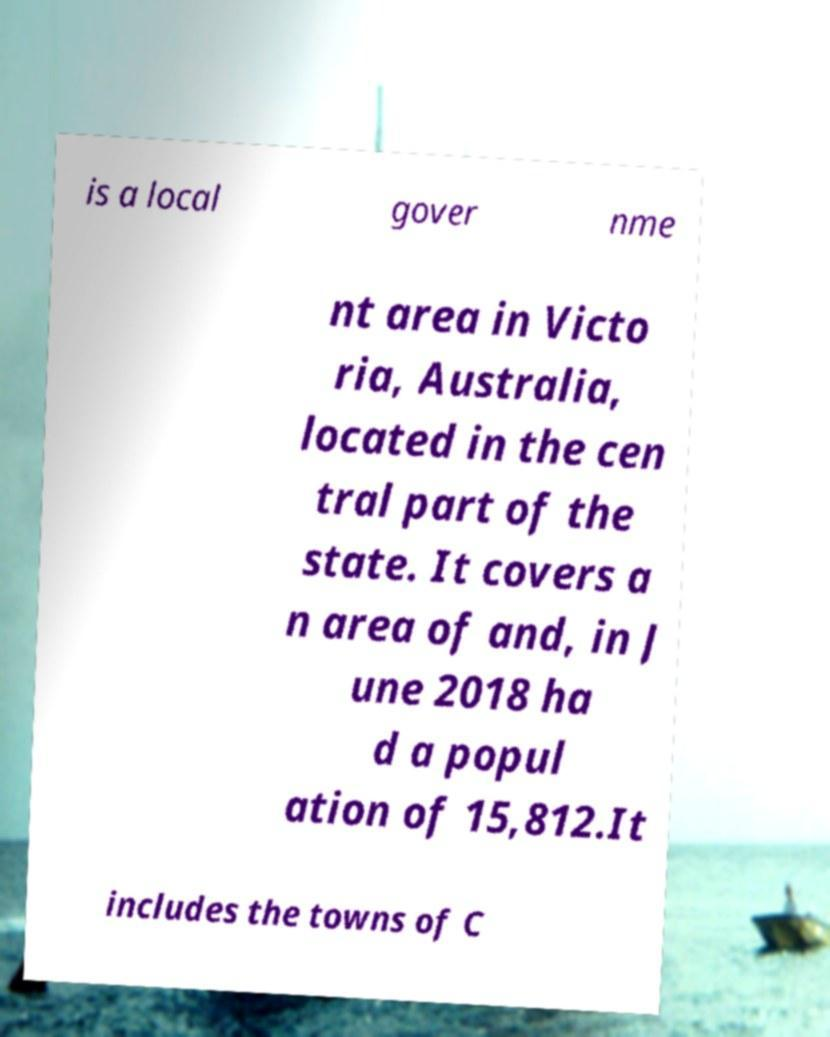I need the written content from this picture converted into text. Can you do that? is a local gover nme nt area in Victo ria, Australia, located in the cen tral part of the state. It covers a n area of and, in J une 2018 ha d a popul ation of 15,812.It includes the towns of C 